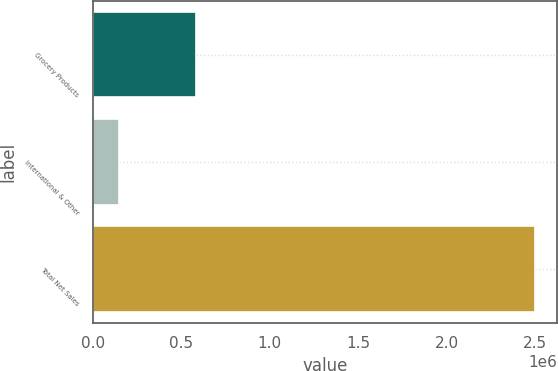<chart> <loc_0><loc_0><loc_500><loc_500><bar_chart><fcel>Grocery Products<fcel>International & Other<fcel>Total Net Sales<nl><fcel>584085<fcel>145907<fcel>2.50151e+06<nl></chart> 